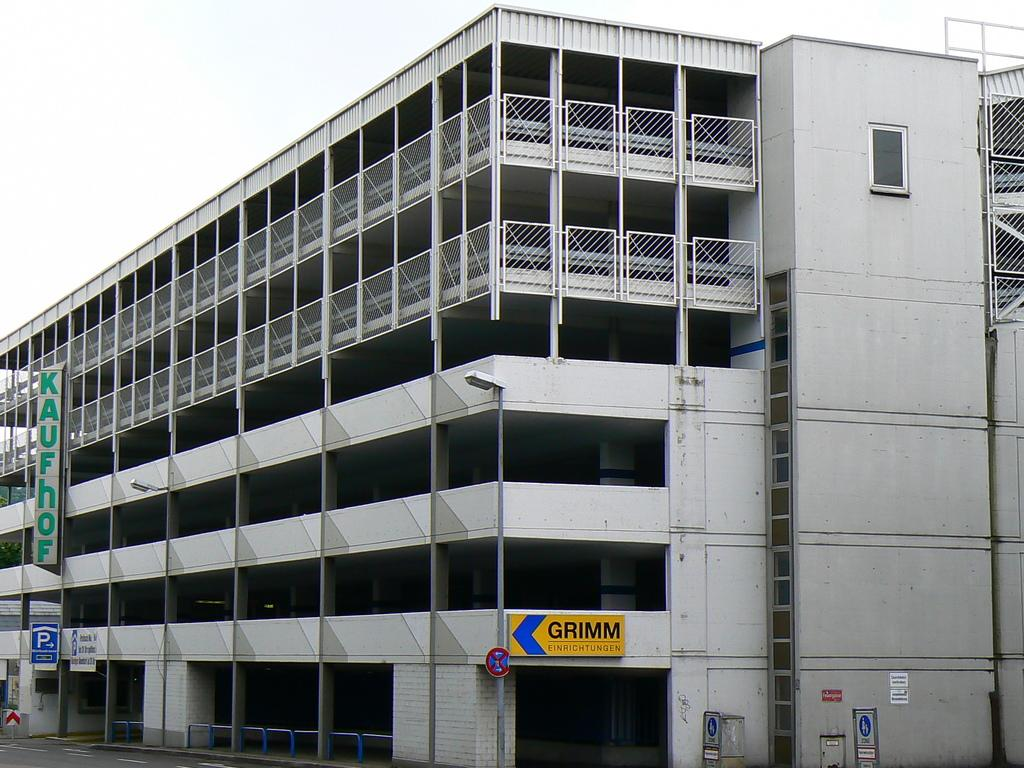What type of structure can be seen in the image? There is a building in the image. What type of security feature is present in the image? Iron grills are present in the image. What type of traffic control feature is visible in the image? Barrier poles are visible in the image. What type of informational signs are in the image? Sign boards are in the image. What type of promotional signs are present in the image? Advertising boards are present in the image. What type of natural element is visible in the image? Trees are visible in the image. What type of celestial element is visible in the image? The sky is visible in the image. What type of lighting feature is present in the image? Street lights are in the image. What type of drink is being advertised on the billboard in the image? There is no billboard or drink present in the image. What type of show is being performed in the image? There is no show or performance present in the image. 